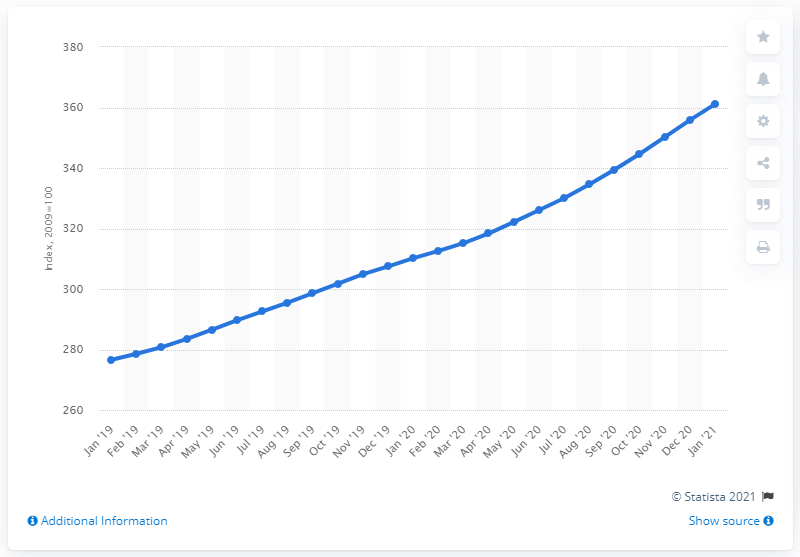Draw attention to some important aspects in this diagram. According to the Consumer Price Index for January 2021 in Nigeria, it was measured at 361.2. 